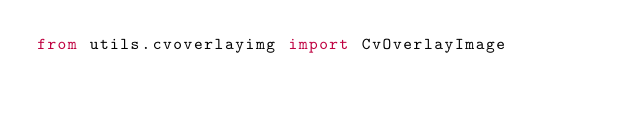<code> <loc_0><loc_0><loc_500><loc_500><_Python_>from utils.cvoverlayimg import CvOverlayImage</code> 